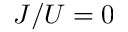<formula> <loc_0><loc_0><loc_500><loc_500>J / U = 0</formula> 